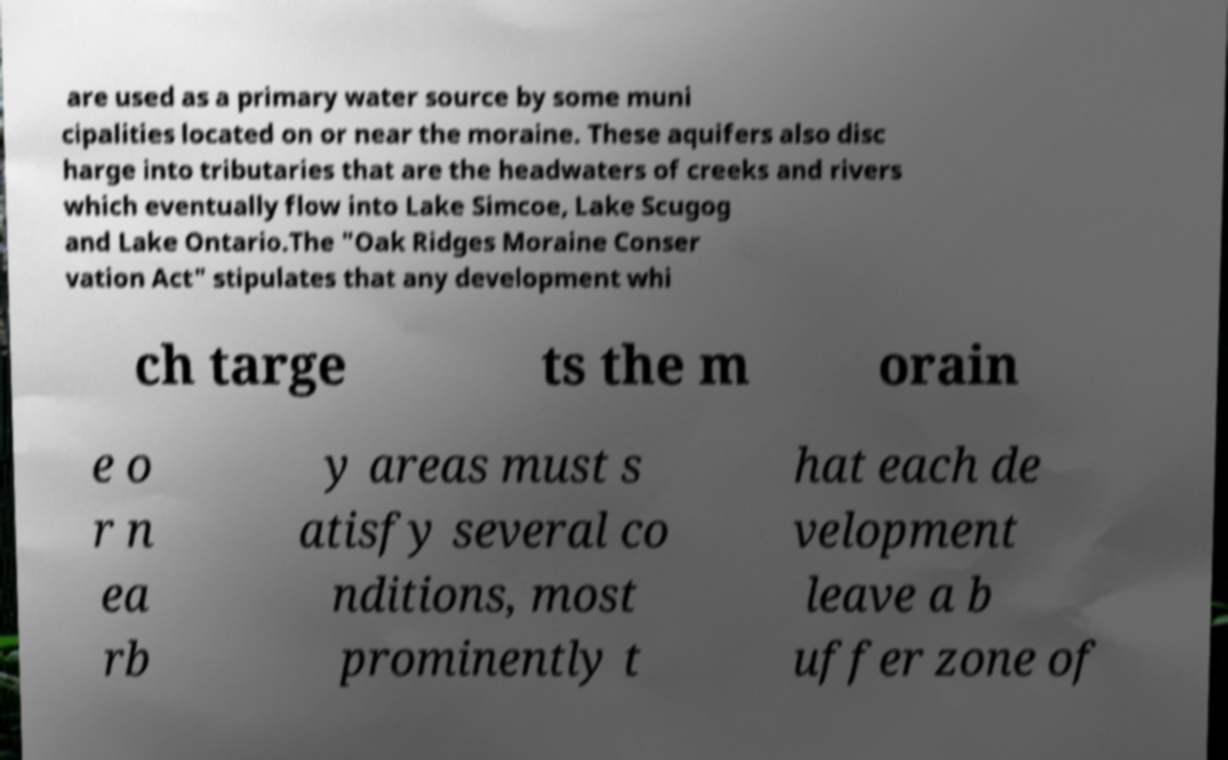I need the written content from this picture converted into text. Can you do that? are used as a primary water source by some muni cipalities located on or near the moraine. These aquifers also disc harge into tributaries that are the headwaters of creeks and rivers which eventually flow into Lake Simcoe, Lake Scugog and Lake Ontario.The "Oak Ridges Moraine Conser vation Act" stipulates that any development whi ch targe ts the m orain e o r n ea rb y areas must s atisfy several co nditions, most prominently t hat each de velopment leave a b uffer zone of 